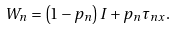Convert formula to latex. <formula><loc_0><loc_0><loc_500><loc_500>W _ { n } = \left ( 1 - p _ { n } \right ) I + p _ { n } \tau _ { n x } .</formula> 